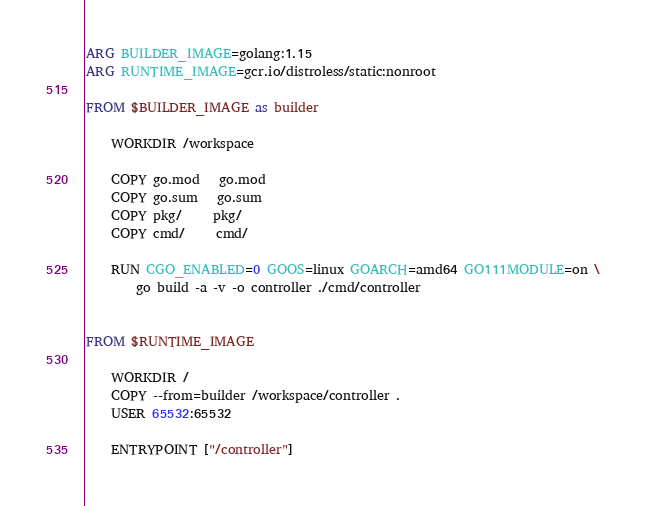Convert code to text. <code><loc_0><loc_0><loc_500><loc_500><_Dockerfile_>ARG BUILDER_IMAGE=golang:1.15
ARG RUNTIME_IMAGE=gcr.io/distroless/static:nonroot

FROM $BUILDER_IMAGE as builder

	WORKDIR /workspace

	COPY go.mod   go.mod
	COPY go.sum   go.sum
	COPY pkg/     pkg/
	COPY cmd/     cmd/

	RUN CGO_ENABLED=0 GOOS=linux GOARCH=amd64 GO111MODULE=on \
		go build -a -v -o controller ./cmd/controller


FROM $RUNTIME_IMAGE

	WORKDIR /
	COPY --from=builder /workspace/controller .
	USER 65532:65532

	ENTRYPOINT ["/controller"]
</code> 